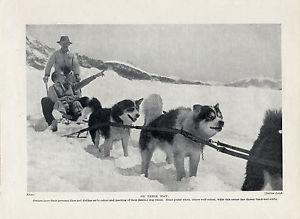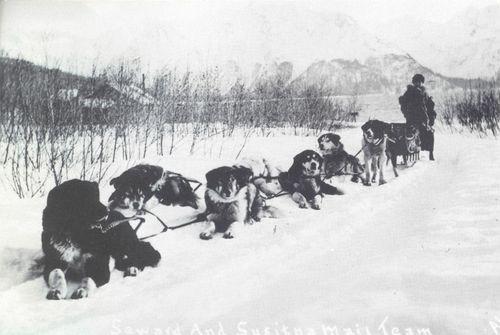The first image is the image on the left, the second image is the image on the right. Analyze the images presented: Is the assertion "Each image shows a dog team with a standing sled driver at the back in a snow-covered field with no business buildings in view." valid? Answer yes or no. Yes. The first image is the image on the left, the second image is the image on the right. For the images shown, is this caption "There are fewer than four people in total." true? Answer yes or no. Yes. 